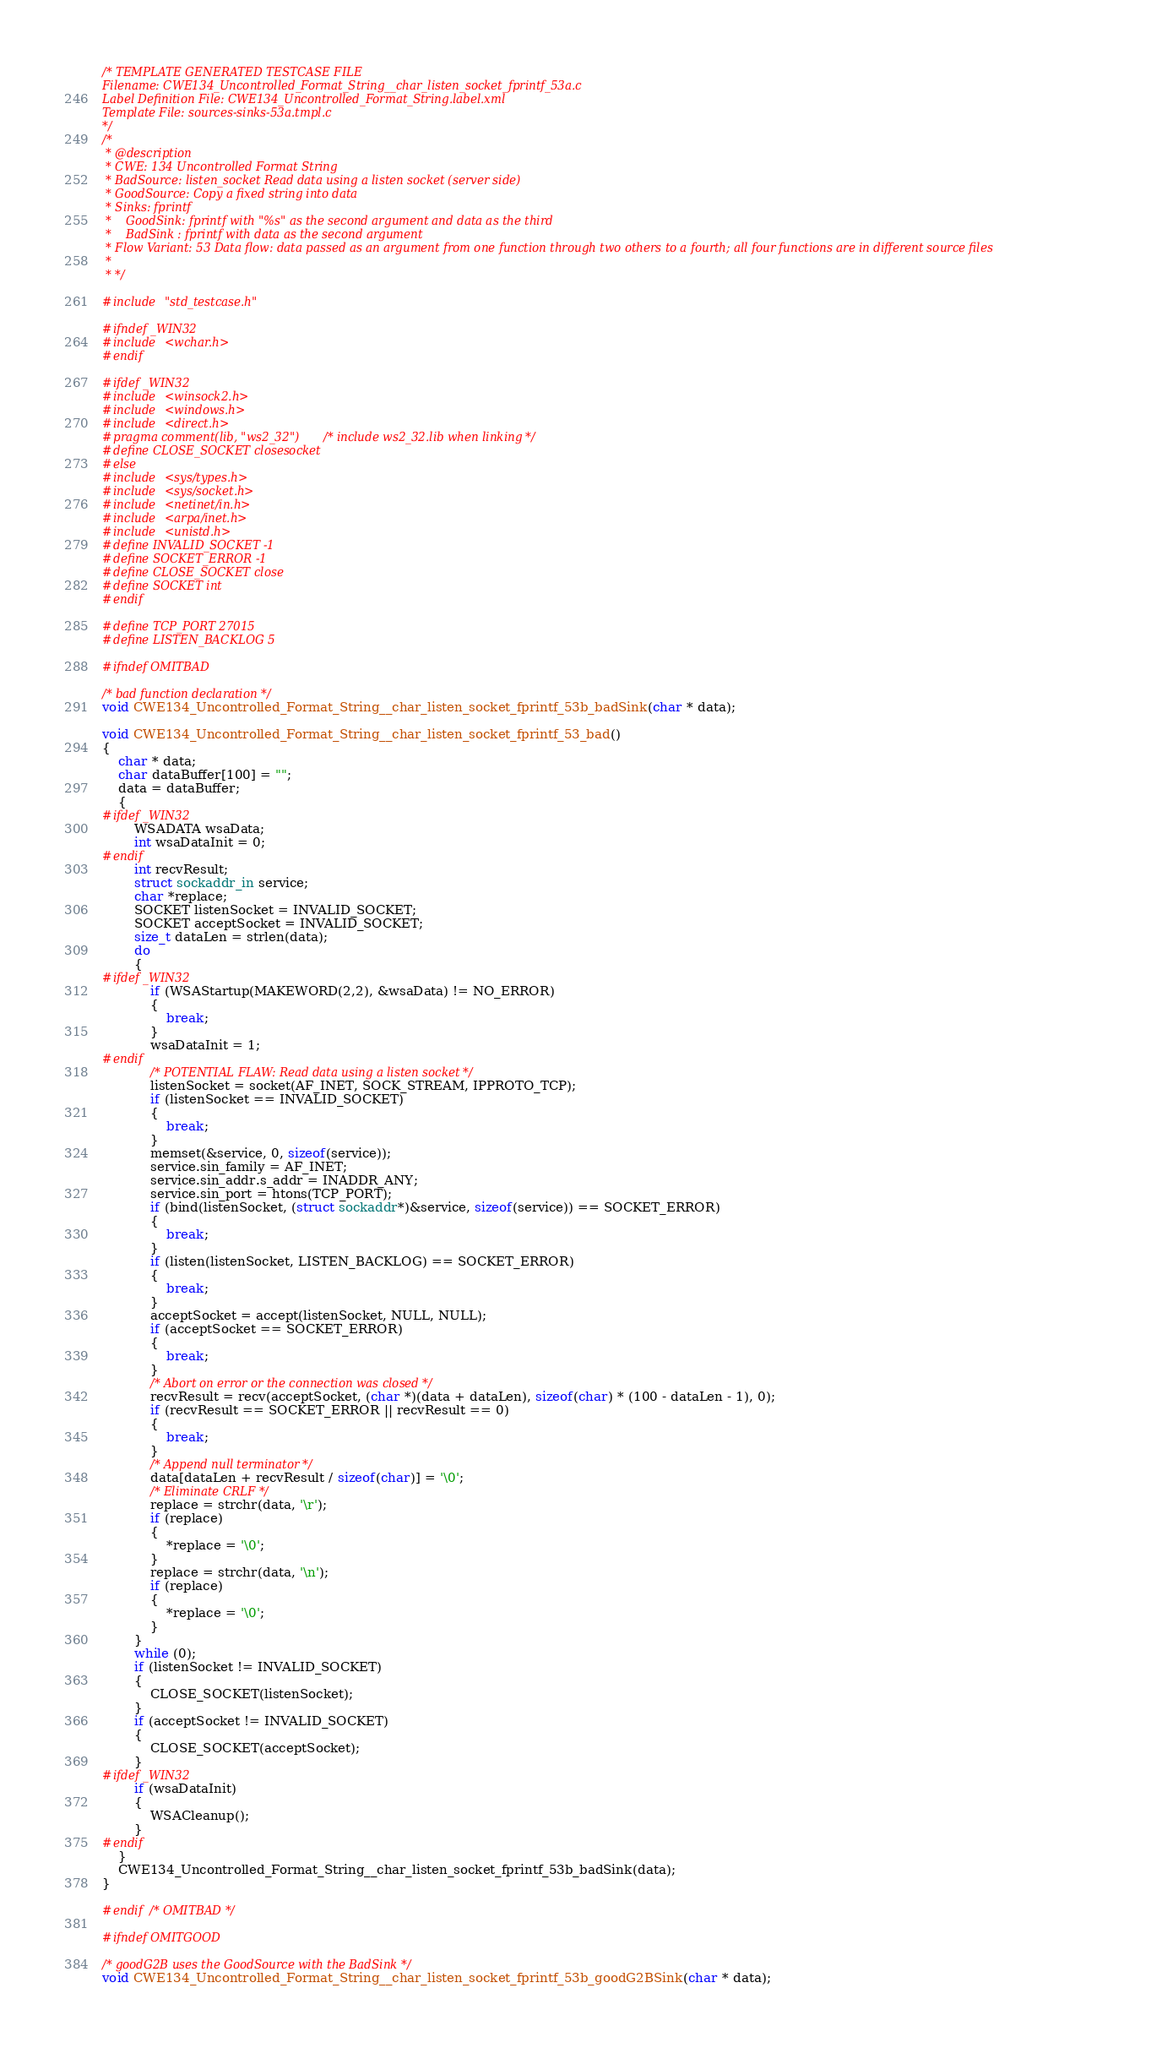<code> <loc_0><loc_0><loc_500><loc_500><_C_>/* TEMPLATE GENERATED TESTCASE FILE
Filename: CWE134_Uncontrolled_Format_String__char_listen_socket_fprintf_53a.c
Label Definition File: CWE134_Uncontrolled_Format_String.label.xml
Template File: sources-sinks-53a.tmpl.c
*/
/*
 * @description
 * CWE: 134 Uncontrolled Format String
 * BadSource: listen_socket Read data using a listen socket (server side)
 * GoodSource: Copy a fixed string into data
 * Sinks: fprintf
 *    GoodSink: fprintf with "%s" as the second argument and data as the third
 *    BadSink : fprintf with data as the second argument
 * Flow Variant: 53 Data flow: data passed as an argument from one function through two others to a fourth; all four functions are in different source files
 *
 * */

#include "std_testcase.h"

#ifndef _WIN32
#include <wchar.h>
#endif

#ifdef _WIN32
#include <winsock2.h>
#include <windows.h>
#include <direct.h>
#pragma comment(lib, "ws2_32") /* include ws2_32.lib when linking */
#define CLOSE_SOCKET closesocket
#else
#include <sys/types.h>
#include <sys/socket.h>
#include <netinet/in.h>
#include <arpa/inet.h>
#include <unistd.h>
#define INVALID_SOCKET -1
#define SOCKET_ERROR -1
#define CLOSE_SOCKET close
#define SOCKET int
#endif

#define TCP_PORT 27015
#define LISTEN_BACKLOG 5

#ifndef OMITBAD

/* bad function declaration */
void CWE134_Uncontrolled_Format_String__char_listen_socket_fprintf_53b_badSink(char * data);

void CWE134_Uncontrolled_Format_String__char_listen_socket_fprintf_53_bad()
{
    char * data;
    char dataBuffer[100] = "";
    data = dataBuffer;
    {
#ifdef _WIN32
        WSADATA wsaData;
        int wsaDataInit = 0;
#endif
        int recvResult;
        struct sockaddr_in service;
        char *replace;
        SOCKET listenSocket = INVALID_SOCKET;
        SOCKET acceptSocket = INVALID_SOCKET;
        size_t dataLen = strlen(data);
        do
        {
#ifdef _WIN32
            if (WSAStartup(MAKEWORD(2,2), &wsaData) != NO_ERROR)
            {
                break;
            }
            wsaDataInit = 1;
#endif
            /* POTENTIAL FLAW: Read data using a listen socket */
            listenSocket = socket(AF_INET, SOCK_STREAM, IPPROTO_TCP);
            if (listenSocket == INVALID_SOCKET)
            {
                break;
            }
            memset(&service, 0, sizeof(service));
            service.sin_family = AF_INET;
            service.sin_addr.s_addr = INADDR_ANY;
            service.sin_port = htons(TCP_PORT);
            if (bind(listenSocket, (struct sockaddr*)&service, sizeof(service)) == SOCKET_ERROR)
            {
                break;
            }
            if (listen(listenSocket, LISTEN_BACKLOG) == SOCKET_ERROR)
            {
                break;
            }
            acceptSocket = accept(listenSocket, NULL, NULL);
            if (acceptSocket == SOCKET_ERROR)
            {
                break;
            }
            /* Abort on error or the connection was closed */
            recvResult = recv(acceptSocket, (char *)(data + dataLen), sizeof(char) * (100 - dataLen - 1), 0);
            if (recvResult == SOCKET_ERROR || recvResult == 0)
            {
                break;
            }
            /* Append null terminator */
            data[dataLen + recvResult / sizeof(char)] = '\0';
            /* Eliminate CRLF */
            replace = strchr(data, '\r');
            if (replace)
            {
                *replace = '\0';
            }
            replace = strchr(data, '\n');
            if (replace)
            {
                *replace = '\0';
            }
        }
        while (0);
        if (listenSocket != INVALID_SOCKET)
        {
            CLOSE_SOCKET(listenSocket);
        }
        if (acceptSocket != INVALID_SOCKET)
        {
            CLOSE_SOCKET(acceptSocket);
        }
#ifdef _WIN32
        if (wsaDataInit)
        {
            WSACleanup();
        }
#endif
    }
    CWE134_Uncontrolled_Format_String__char_listen_socket_fprintf_53b_badSink(data);
}

#endif /* OMITBAD */

#ifndef OMITGOOD

/* goodG2B uses the GoodSource with the BadSink */
void CWE134_Uncontrolled_Format_String__char_listen_socket_fprintf_53b_goodG2BSink(char * data);
</code> 